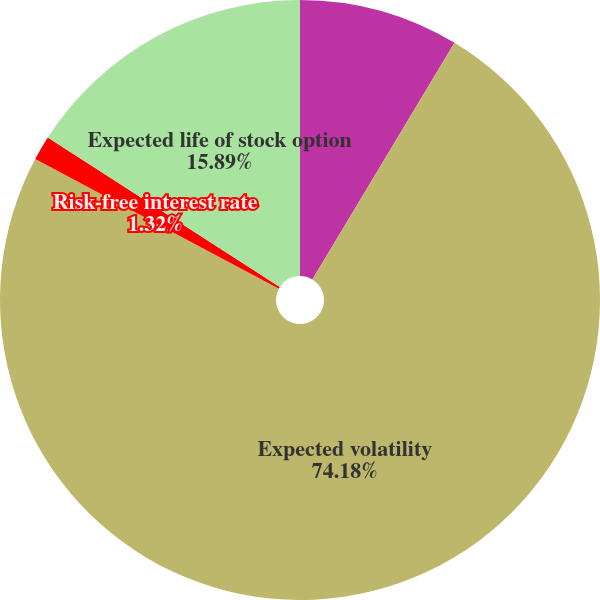Convert chart. <chart><loc_0><loc_0><loc_500><loc_500><pie_chart><fcel>Dividend yield<fcel>Expected volatility<fcel>Risk-free interest rate<fcel>Expected life of stock option<nl><fcel>8.61%<fcel>74.18%<fcel>1.32%<fcel>15.89%<nl></chart> 